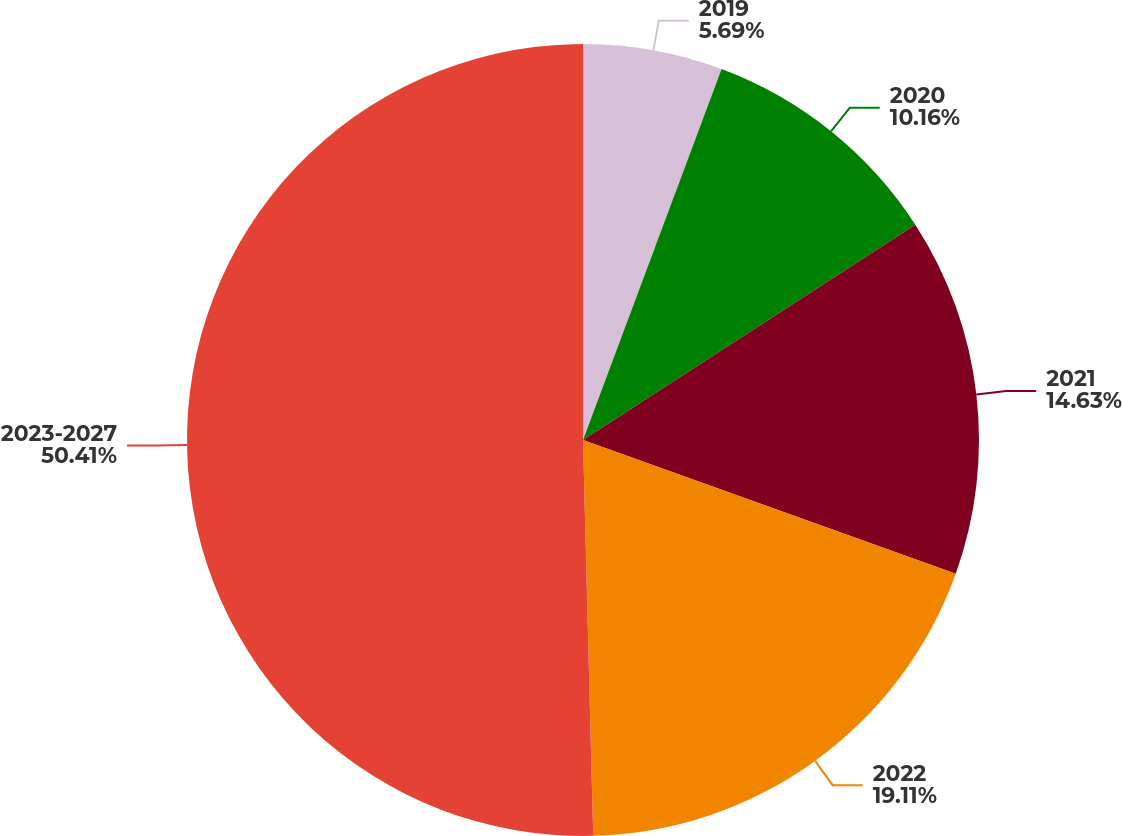Convert chart. <chart><loc_0><loc_0><loc_500><loc_500><pie_chart><fcel>2019<fcel>2020<fcel>2021<fcel>2022<fcel>2023-2027<nl><fcel>5.69%<fcel>10.16%<fcel>14.63%<fcel>19.11%<fcel>50.41%<nl></chart> 